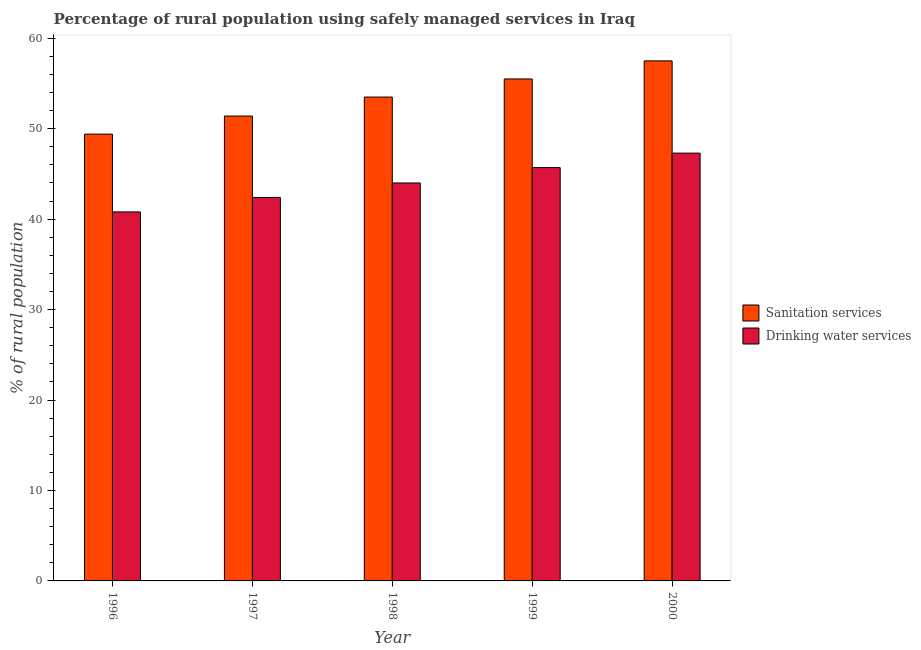How many groups of bars are there?
Ensure brevity in your answer.  5. Are the number of bars per tick equal to the number of legend labels?
Your response must be concise. Yes. How many bars are there on the 2nd tick from the left?
Offer a terse response. 2. How many bars are there on the 4th tick from the right?
Give a very brief answer. 2. What is the label of the 2nd group of bars from the left?
Give a very brief answer. 1997. In how many cases, is the number of bars for a given year not equal to the number of legend labels?
Offer a very short reply. 0. What is the percentage of rural population who used sanitation services in 1999?
Give a very brief answer. 55.5. Across all years, what is the maximum percentage of rural population who used drinking water services?
Make the answer very short. 47.3. Across all years, what is the minimum percentage of rural population who used drinking water services?
Give a very brief answer. 40.8. In which year was the percentage of rural population who used drinking water services minimum?
Offer a very short reply. 1996. What is the total percentage of rural population who used drinking water services in the graph?
Your answer should be very brief. 220.2. What is the difference between the percentage of rural population who used drinking water services in 1998 and that in 2000?
Offer a terse response. -3.3. What is the difference between the percentage of rural population who used drinking water services in 1997 and the percentage of rural population who used sanitation services in 1996?
Provide a succinct answer. 1.6. What is the average percentage of rural population who used sanitation services per year?
Offer a terse response. 53.46. What is the ratio of the percentage of rural population who used sanitation services in 1998 to that in 2000?
Make the answer very short. 0.93. Is the percentage of rural population who used sanitation services in 1997 less than that in 1998?
Provide a succinct answer. Yes. Is the difference between the percentage of rural population who used sanitation services in 1996 and 2000 greater than the difference between the percentage of rural population who used drinking water services in 1996 and 2000?
Make the answer very short. No. What is the difference between the highest and the second highest percentage of rural population who used drinking water services?
Offer a terse response. 1.6. In how many years, is the percentage of rural population who used sanitation services greater than the average percentage of rural population who used sanitation services taken over all years?
Offer a terse response. 3. Is the sum of the percentage of rural population who used drinking water services in 1997 and 1999 greater than the maximum percentage of rural population who used sanitation services across all years?
Make the answer very short. Yes. What does the 2nd bar from the left in 1999 represents?
Your answer should be compact. Drinking water services. What does the 1st bar from the right in 1997 represents?
Your answer should be compact. Drinking water services. How many bars are there?
Keep it short and to the point. 10. How many years are there in the graph?
Give a very brief answer. 5. What is the difference between two consecutive major ticks on the Y-axis?
Offer a terse response. 10. Are the values on the major ticks of Y-axis written in scientific E-notation?
Make the answer very short. No. Does the graph contain grids?
Your response must be concise. No. How many legend labels are there?
Keep it short and to the point. 2. How are the legend labels stacked?
Your response must be concise. Vertical. What is the title of the graph?
Provide a short and direct response. Percentage of rural population using safely managed services in Iraq. What is the label or title of the X-axis?
Provide a succinct answer. Year. What is the label or title of the Y-axis?
Offer a terse response. % of rural population. What is the % of rural population of Sanitation services in 1996?
Give a very brief answer. 49.4. What is the % of rural population of Drinking water services in 1996?
Provide a short and direct response. 40.8. What is the % of rural population of Sanitation services in 1997?
Your answer should be compact. 51.4. What is the % of rural population of Drinking water services in 1997?
Offer a very short reply. 42.4. What is the % of rural population in Sanitation services in 1998?
Give a very brief answer. 53.5. What is the % of rural population in Drinking water services in 1998?
Your answer should be very brief. 44. What is the % of rural population in Sanitation services in 1999?
Your answer should be compact. 55.5. What is the % of rural population of Drinking water services in 1999?
Your answer should be very brief. 45.7. What is the % of rural population of Sanitation services in 2000?
Ensure brevity in your answer.  57.5. What is the % of rural population in Drinking water services in 2000?
Your response must be concise. 47.3. Across all years, what is the maximum % of rural population in Sanitation services?
Your answer should be compact. 57.5. Across all years, what is the maximum % of rural population of Drinking water services?
Provide a succinct answer. 47.3. Across all years, what is the minimum % of rural population in Sanitation services?
Your answer should be compact. 49.4. Across all years, what is the minimum % of rural population in Drinking water services?
Provide a short and direct response. 40.8. What is the total % of rural population of Sanitation services in the graph?
Provide a succinct answer. 267.3. What is the total % of rural population of Drinking water services in the graph?
Offer a very short reply. 220.2. What is the difference between the % of rural population in Sanitation services in 1996 and that in 1997?
Ensure brevity in your answer.  -2. What is the difference between the % of rural population in Sanitation services in 1996 and that in 1998?
Keep it short and to the point. -4.1. What is the difference between the % of rural population in Drinking water services in 1996 and that in 1998?
Your response must be concise. -3.2. What is the difference between the % of rural population of Drinking water services in 1996 and that in 1999?
Provide a succinct answer. -4.9. What is the difference between the % of rural population of Drinking water services in 1996 and that in 2000?
Offer a very short reply. -6.5. What is the difference between the % of rural population in Drinking water services in 1997 and that in 1998?
Your answer should be compact. -1.6. What is the difference between the % of rural population of Drinking water services in 1997 and that in 1999?
Offer a very short reply. -3.3. What is the difference between the % of rural population of Sanitation services in 1998 and that in 1999?
Offer a very short reply. -2. What is the difference between the % of rural population in Drinking water services in 1998 and that in 2000?
Ensure brevity in your answer.  -3.3. What is the difference between the % of rural population of Sanitation services in 1999 and that in 2000?
Keep it short and to the point. -2. What is the difference between the % of rural population of Drinking water services in 1999 and that in 2000?
Offer a very short reply. -1.6. What is the difference between the % of rural population of Sanitation services in 1996 and the % of rural population of Drinking water services in 1999?
Provide a succinct answer. 3.7. What is the difference between the % of rural population of Sanitation services in 1996 and the % of rural population of Drinking water services in 2000?
Ensure brevity in your answer.  2.1. What is the difference between the % of rural population of Sanitation services in 1997 and the % of rural population of Drinking water services in 1998?
Ensure brevity in your answer.  7.4. What is the difference between the % of rural population of Sanitation services in 1997 and the % of rural population of Drinking water services in 1999?
Offer a terse response. 5.7. What is the difference between the % of rural population in Sanitation services in 1998 and the % of rural population in Drinking water services in 1999?
Keep it short and to the point. 7.8. What is the difference between the % of rural population of Sanitation services in 1998 and the % of rural population of Drinking water services in 2000?
Offer a very short reply. 6.2. What is the average % of rural population in Sanitation services per year?
Make the answer very short. 53.46. What is the average % of rural population of Drinking water services per year?
Offer a terse response. 44.04. In the year 1996, what is the difference between the % of rural population in Sanitation services and % of rural population in Drinking water services?
Keep it short and to the point. 8.6. In the year 1999, what is the difference between the % of rural population in Sanitation services and % of rural population in Drinking water services?
Your answer should be very brief. 9.8. In the year 2000, what is the difference between the % of rural population in Sanitation services and % of rural population in Drinking water services?
Make the answer very short. 10.2. What is the ratio of the % of rural population of Sanitation services in 1996 to that in 1997?
Your answer should be compact. 0.96. What is the ratio of the % of rural population of Drinking water services in 1996 to that in 1997?
Make the answer very short. 0.96. What is the ratio of the % of rural population in Sanitation services in 1996 to that in 1998?
Give a very brief answer. 0.92. What is the ratio of the % of rural population in Drinking water services in 1996 to that in 1998?
Make the answer very short. 0.93. What is the ratio of the % of rural population of Sanitation services in 1996 to that in 1999?
Keep it short and to the point. 0.89. What is the ratio of the % of rural population of Drinking water services in 1996 to that in 1999?
Provide a succinct answer. 0.89. What is the ratio of the % of rural population in Sanitation services in 1996 to that in 2000?
Your response must be concise. 0.86. What is the ratio of the % of rural population of Drinking water services in 1996 to that in 2000?
Ensure brevity in your answer.  0.86. What is the ratio of the % of rural population of Sanitation services in 1997 to that in 1998?
Offer a very short reply. 0.96. What is the ratio of the % of rural population in Drinking water services in 1997 to that in 1998?
Ensure brevity in your answer.  0.96. What is the ratio of the % of rural population in Sanitation services in 1997 to that in 1999?
Your answer should be very brief. 0.93. What is the ratio of the % of rural population of Drinking water services in 1997 to that in 1999?
Your response must be concise. 0.93. What is the ratio of the % of rural population of Sanitation services in 1997 to that in 2000?
Your response must be concise. 0.89. What is the ratio of the % of rural population in Drinking water services in 1997 to that in 2000?
Your answer should be compact. 0.9. What is the ratio of the % of rural population of Drinking water services in 1998 to that in 1999?
Offer a very short reply. 0.96. What is the ratio of the % of rural population of Sanitation services in 1998 to that in 2000?
Keep it short and to the point. 0.93. What is the ratio of the % of rural population in Drinking water services in 1998 to that in 2000?
Provide a succinct answer. 0.93. What is the ratio of the % of rural population in Sanitation services in 1999 to that in 2000?
Ensure brevity in your answer.  0.97. What is the ratio of the % of rural population in Drinking water services in 1999 to that in 2000?
Provide a short and direct response. 0.97. What is the difference between the highest and the lowest % of rural population in Sanitation services?
Provide a succinct answer. 8.1. What is the difference between the highest and the lowest % of rural population of Drinking water services?
Ensure brevity in your answer.  6.5. 